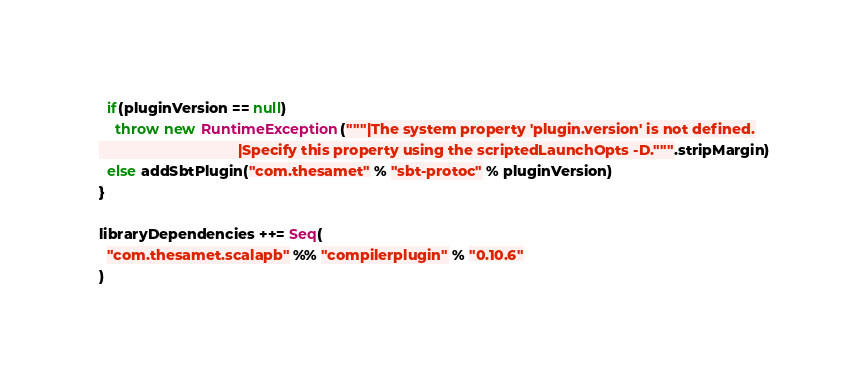Convert code to text. <code><loc_0><loc_0><loc_500><loc_500><_Scala_>  if(pluginVersion == null)
    throw new RuntimeException("""|The system property 'plugin.version' is not defined.
                                  |Specify this property using the scriptedLaunchOpts -D.""".stripMargin)
  else addSbtPlugin("com.thesamet" % "sbt-protoc" % pluginVersion)
}

libraryDependencies ++= Seq(
  "com.thesamet.scalapb" %% "compilerplugin" % "0.10.6"
)
</code> 